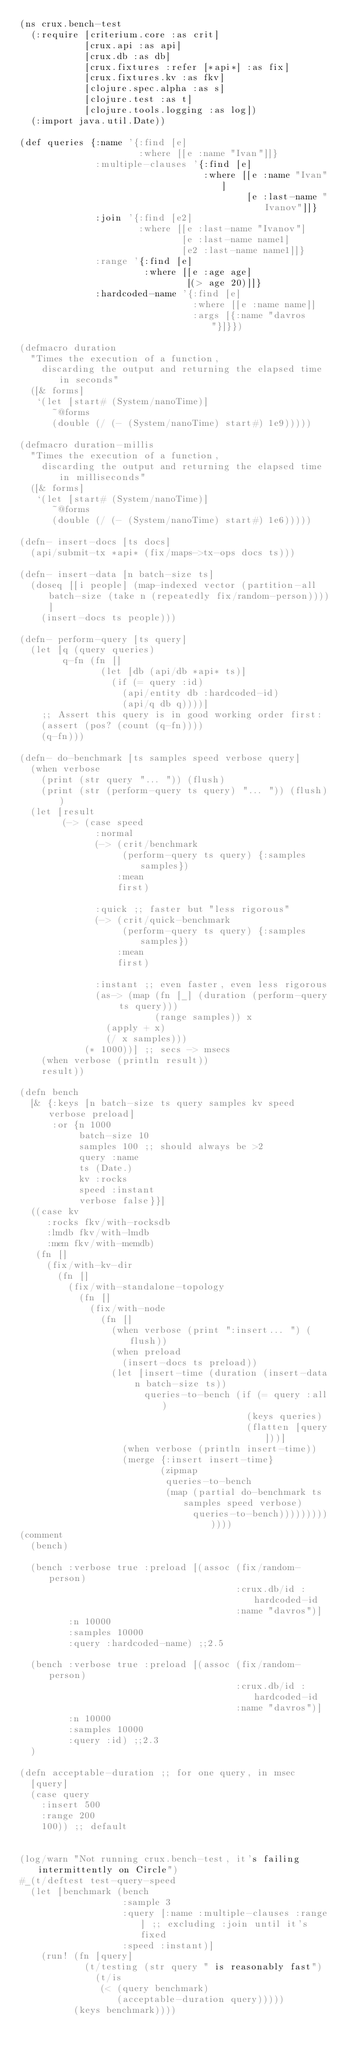<code> <loc_0><loc_0><loc_500><loc_500><_Clojure_>(ns crux.bench-test
  (:require [criterium.core :as crit]
            [crux.api :as api]
            [crux.db :as db]
            [crux.fixtures :refer [*api*] :as fix]
            [crux.fixtures.kv :as fkv]
            [clojure.spec.alpha :as s]
            [clojure.test :as t]
            [clojure.tools.logging :as log])
  (:import java.util.Date))

(def queries {:name '{:find [e]
                      :where [[e :name "Ivan"]]}
              :multiple-clauses '{:find [e]
                                  :where [[e :name "Ivan"]
                                          [e :last-name "Ivanov"]]}
              :join '{:find [e2]
                      :where [[e :last-name "Ivanov"]
                              [e :last-name name1]
                              [e2 :last-name name1]]}
              :range '{:find [e]
                       :where [[e :age age]
                               [(> age 20)]]}
              :hardcoded-name '{:find [e]
                                :where [[e :name name]]
                                :args [{:name "davros"}]}})

(defmacro duration
  "Times the execution of a function,
    discarding the output and returning the elapsed time in seconds"
  ([& forms]
   `(let [start# (System/nanoTime)]
      ~@forms
      (double (/ (- (System/nanoTime) start#) 1e9)))))

(defmacro duration-millis
  "Times the execution of a function,
    discarding the output and returning the elapsed time in milliseconds"
  ([& forms]
   `(let [start# (System/nanoTime)]
      ~@forms
      (double (/ (- (System/nanoTime) start#) 1e6)))))

(defn- insert-docs [ts docs]
  (api/submit-tx *api* (fix/maps->tx-ops docs ts)))

(defn- insert-data [n batch-size ts]
  (doseq [[i people] (map-indexed vector (partition-all batch-size (take n (repeatedly fix/random-person))))]
    (insert-docs ts people)))

(defn- perform-query [ts query]
  (let [q (query queries)
        q-fn (fn []
               (let [db (api/db *api* ts)]
                 (if (= query :id)
                   (api/entity db :hardcoded-id)
                   (api/q db q))))]
    ;; Assert this query is in good working order first:
    (assert (pos? (count (q-fn))))
    (q-fn)))

(defn- do-benchmark [ts samples speed verbose query]
  (when verbose
    (print (str query "... ")) (flush)
    (print (str (perform-query ts query) "... ")) (flush))
  (let [result
        (-> (case speed
              :normal
              (-> (crit/benchmark
                   (perform-query ts query) {:samples samples})
                  :mean
                  first)

              :quick ;; faster but "less rigorous"
              (-> (crit/quick-benchmark
                   (perform-query ts query) {:samples samples})
                  :mean
                  first)

              :instant ;; even faster, even less rigorous
              (as-> (map (fn [_] (duration (perform-query ts query)))
                         (range samples)) x
                (apply + x)
                (/ x samples)))
            (* 1000))] ;; secs -> msecs
    (when verbose (println result))
    result))

(defn bench
  [& {:keys [n batch-size ts query samples kv speed verbose preload]
      :or {n 1000
           batch-size 10
           samples 100 ;; should always be >2
           query :name
           ts (Date.)
           kv :rocks
           speed :instant
           verbose false}}]
  ((case kv
     :rocks fkv/with-rocksdb
     :lmdb fkv/with-lmdb
     :mem fkv/with-memdb)
   (fn []
     (fix/with-kv-dir
       (fn []
         (fix/with-standalone-topology
           (fn []
             (fix/with-node
               (fn []
                 (when verbose (print ":insert... ") (flush))
                 (when preload
                   (insert-docs ts preload))
                 (let [insert-time (duration (insert-data n batch-size ts))
                       queries-to-bench (if (= query :all)
                                          (keys queries)
                                          (flatten [query]))]
                   (when verbose (println insert-time))
                   (merge {:insert insert-time}
                          (zipmap
                           queries-to-bench
                           (map (partial do-benchmark ts samples speed verbose)
                                queries-to-bench)))))))))))))
(comment
  (bench)

  (bench :verbose true :preload [(assoc (fix/random-person)
                                        :crux.db/id :hardcoded-id
                                        :name "davros")]
         :n 10000
         :samples 10000
         :query :hardcoded-name) ;;2.5

  (bench :verbose true :preload [(assoc (fix/random-person)
                                        :crux.db/id :hardcoded-id
                                        :name "davros")]
         :n 10000
         :samples 10000
         :query :id) ;;2.3
  )

(defn acceptable-duration ;; for one query, in msec
  [query]
  (case query
    :insert 500
    :range 200
    100)) ;; default


(log/warn "Not running crux.bench-test, it's failing intermittently on Circle")
#_(t/deftest test-query-speed
  (let [benchmark (bench
                   :sample 3
                   :query [:name :multiple-clauses :range] ;; excluding :join until it's fixed
                   :speed :instant)]
    (run! (fn [query]
            (t/testing (str query " is reasonably fast")
              (t/is
               (< (query benchmark)
                  (acceptable-duration query)))))
          (keys benchmark))))
</code> 